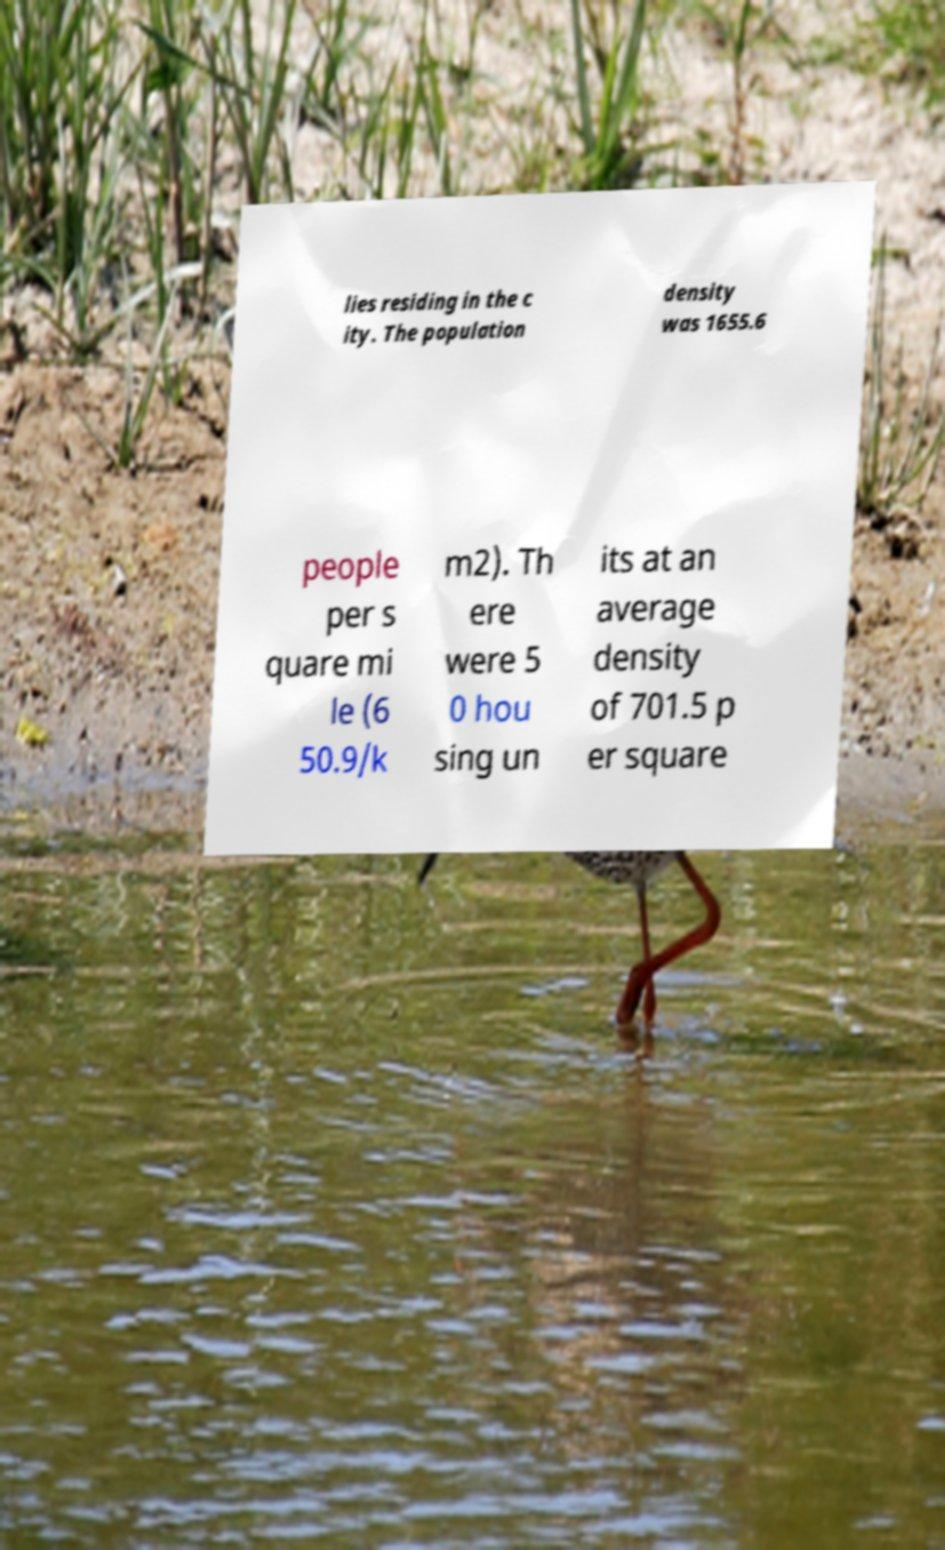For documentation purposes, I need the text within this image transcribed. Could you provide that? lies residing in the c ity. The population density was 1655.6 people per s quare mi le (6 50.9/k m2). Th ere were 5 0 hou sing un its at an average density of 701.5 p er square 